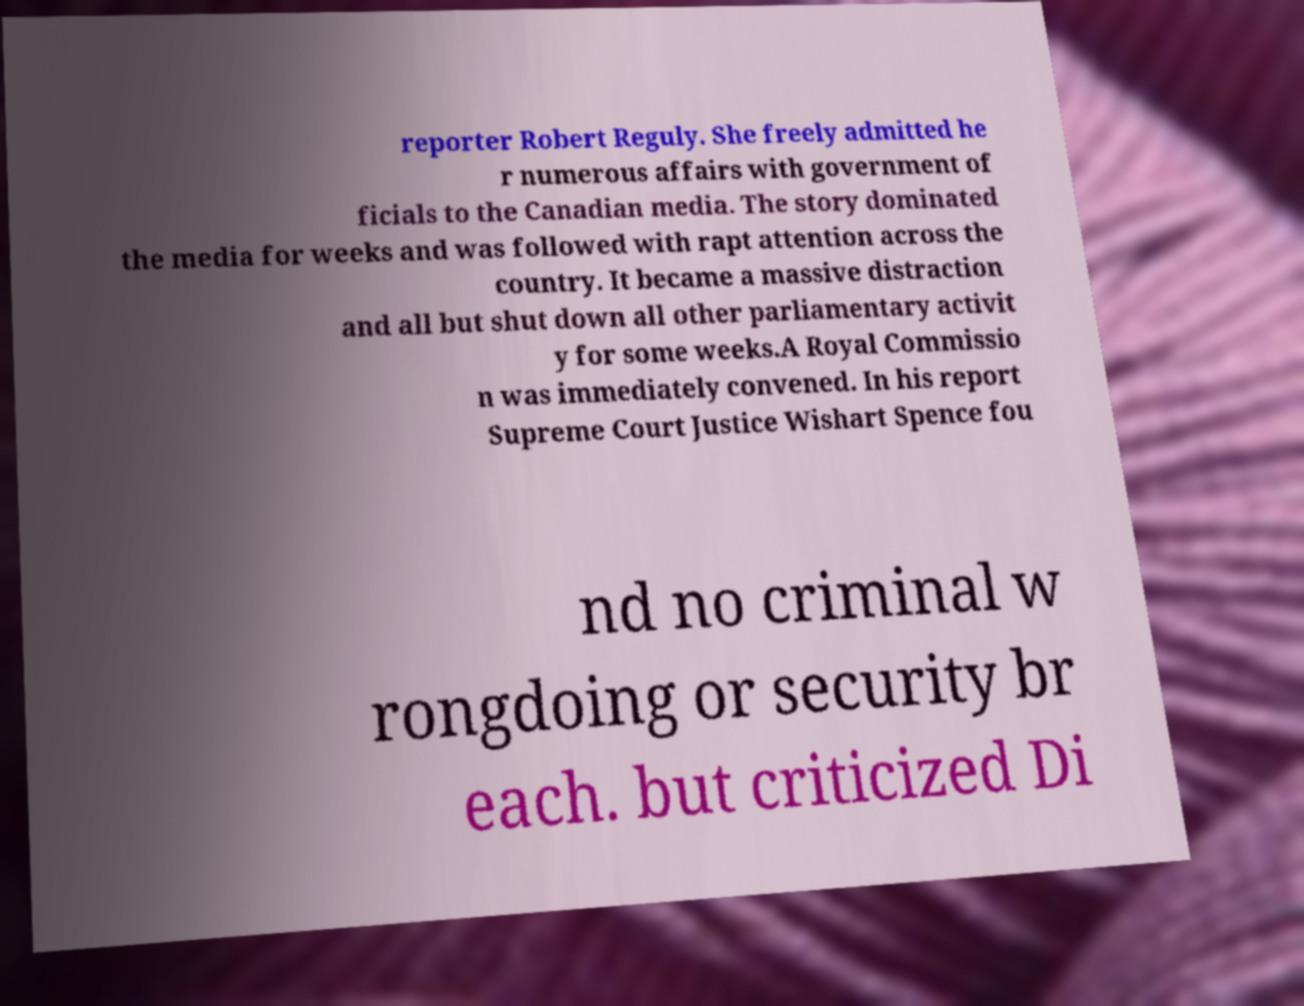What messages or text are displayed in this image? I need them in a readable, typed format. reporter Robert Reguly. She freely admitted he r numerous affairs with government of ficials to the Canadian media. The story dominated the media for weeks and was followed with rapt attention across the country. It became a massive distraction and all but shut down all other parliamentary activit y for some weeks.A Royal Commissio n was immediately convened. In his report Supreme Court Justice Wishart Spence fou nd no criminal w rongdoing or security br each. but criticized Di 